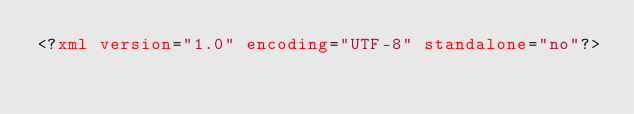Convert code to text. <code><loc_0><loc_0><loc_500><loc_500><_XML_><?xml version="1.0" encoding="UTF-8" standalone="no"?></code> 